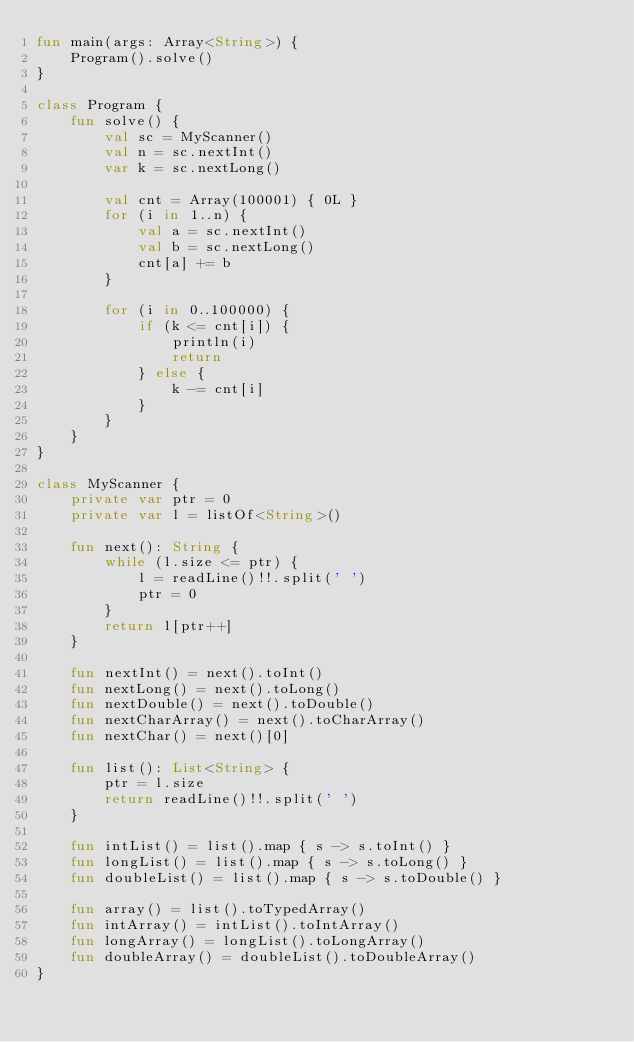Convert code to text. <code><loc_0><loc_0><loc_500><loc_500><_Kotlin_>fun main(args: Array<String>) {
    Program().solve()
}

class Program {
    fun solve() {
        val sc = MyScanner()
        val n = sc.nextInt()
        var k = sc.nextLong()

        val cnt = Array(100001) { 0L }
        for (i in 1..n) {
            val a = sc.nextInt()
            val b = sc.nextLong()
            cnt[a] += b
        }

        for (i in 0..100000) {
            if (k <= cnt[i]) {
                println(i)
                return
            } else {
                k -= cnt[i]
            }
        }
    }
}

class MyScanner {
    private var ptr = 0
    private var l = listOf<String>()

    fun next(): String {
        while (l.size <= ptr) {
            l = readLine()!!.split(' ')
            ptr = 0
        }
        return l[ptr++]
    }

    fun nextInt() = next().toInt()
    fun nextLong() = next().toLong()
    fun nextDouble() = next().toDouble()
    fun nextCharArray() = next().toCharArray()
    fun nextChar() = next()[0]

    fun list(): List<String> {
        ptr = l.size
        return readLine()!!.split(' ')
    }

    fun intList() = list().map { s -> s.toInt() }
    fun longList() = list().map { s -> s.toLong() }
    fun doubleList() = list().map { s -> s.toDouble() }

    fun array() = list().toTypedArray()
    fun intArray() = intList().toIntArray()
    fun longArray() = longList().toLongArray()
    fun doubleArray() = doubleList().toDoubleArray()
}
</code> 